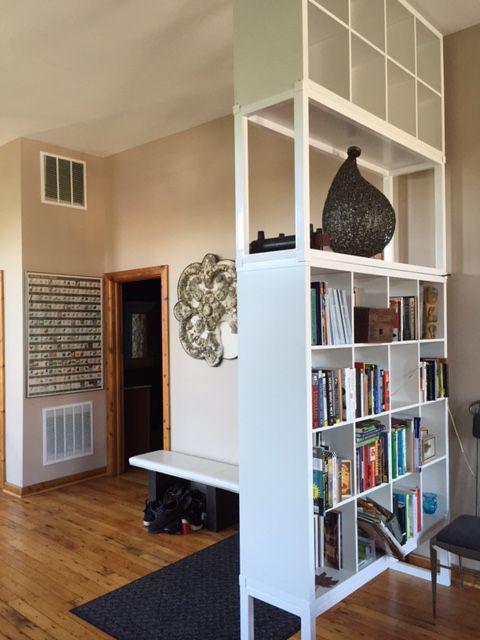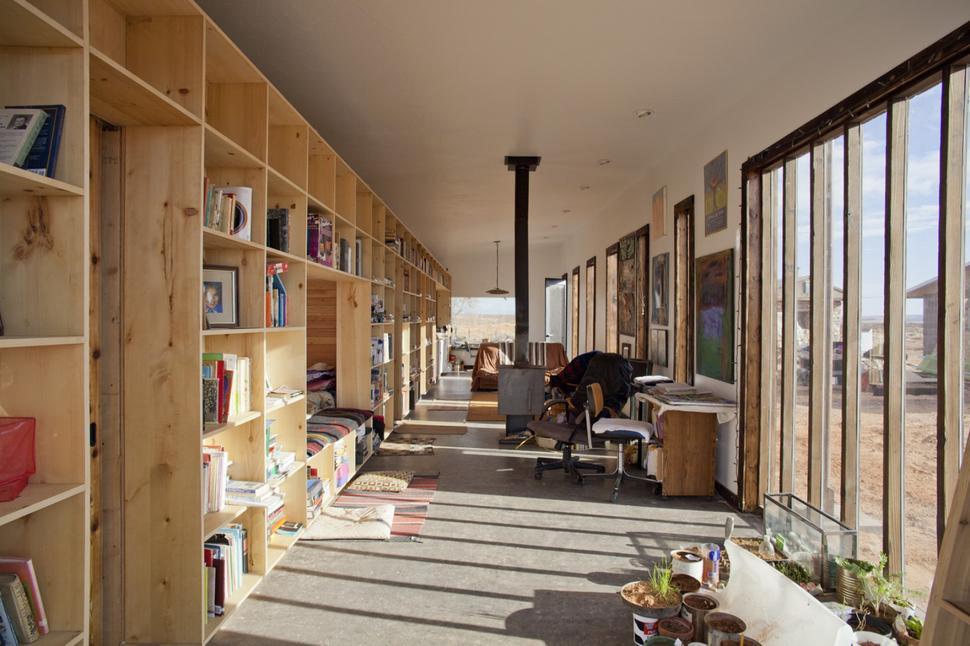The first image is the image on the left, the second image is the image on the right. Examine the images to the left and right. Is the description "One of the bookshelves has decorative items on top as well as on the shelves." accurate? Answer yes or no. No. The first image is the image on the left, the second image is the image on the right. Considering the images on both sides, is "In each image, a wide white shelving unit is placed perpendicular to a wall to create a room divider." valid? Answer yes or no. No. 